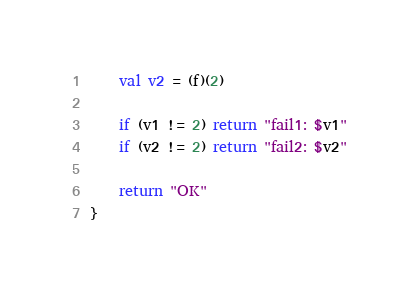Convert code to text. <code><loc_0><loc_0><loc_500><loc_500><_Kotlin_>    val v2 = (f)(2)

    if (v1 != 2) return "fail1: $v1"
    if (v2 != 2) return "fail2: $v2"

    return "OK"
}
</code> 